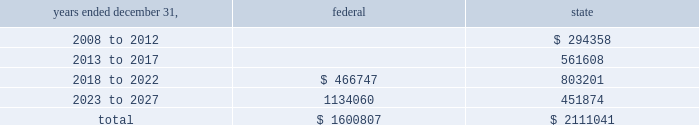American tower corporation and subsidiaries notes to consolidated financial statements 2014 ( continued ) for the years ended december 31 , 2007 and 2006 , the company increased net deferred tax assets by $ 1.5 million and $ 7.2 million , respectively with a corresponding reduction of goodwill associated with the utilization of net operating and capital losses acquired in connection with the spectrasite , inc .
Merger .
These deferred tax assets were assigned a full valuation allowance as part of the final spectrasite purchase price allocation in june 2006 , as evidence available at the time did not support that losses were more likely than not to be realized .
The valuation allowance decreased from $ 308.2 million as of december 31 , 2006 to $ 88.2 million as of december 31 , 2007 .
The decrease was primarily due to a $ 149.6 million reclassification to the fin 48 opening balance ( related to federal and state net operating losses acquired in connection with the spectrasite , inc .
Merger ) and $ 45.2 million of allowance reductions during the year ended december 31 , 2007 related to state net operating losses , capital loss expirations of $ 6.5 million and other items .
The company 2019s deferred tax assets as of december 31 , 2007 and 2006 in the table above do not include $ 74.9 million and $ 31.0 million , respectively , of excess tax benefits from the exercises of employee stock options that are a component of net operating losses due to the adoption of sfas no .
123r .
Total stockholders 2019 equity will be increased by $ 74.9 million if and when any such excess tax benefits are ultimately realized .
Basis step-up from corporate restructuring represents the tax effects of increasing the basis for tax purposes of certain of the company 2019s assets in conjunction with its spin-off from american radio systems corporation , its former parent company .
At december 31 , 2007 , the company had net federal and state operating loss carryforwards available to reduce future federal and state taxable income of approximately $ 1.6 billion and $ 2.1 billion , respectively .
If not utilized , the company 2019s net operating loss carryforwards expire as follows ( in thousands ) : .
As described in note 1 , the company adopted the provisions of fin 48 on january 1 , 2007 .
As of january 1 , 2007 , the total amount of unrecognized tax benefits was $ 183.9 million of which $ 34.3 million would affect the effective tax rate , if recognized .
As of december 31 , 2007 , the total amount of unrecognized tax benefits was $ 59.2 million , $ 23.0 million of which would affect the effective tax rate , if recognized .
The company expects the unrecognized tax benefits to change over the next 12 months if certain tax matters ultimately settle with the applicable taxing jurisdiction during this timeframe .
However , based on the status of these items and the amount of uncertainty associated with the outcome and timing of audit settlements , the .
What portion of the unrecognized tax benefits would affect the effective tax rate if recognized as of december 31 , 2007? 
Computations: (23.0 / 59.2)
Answer: 0.38851. 